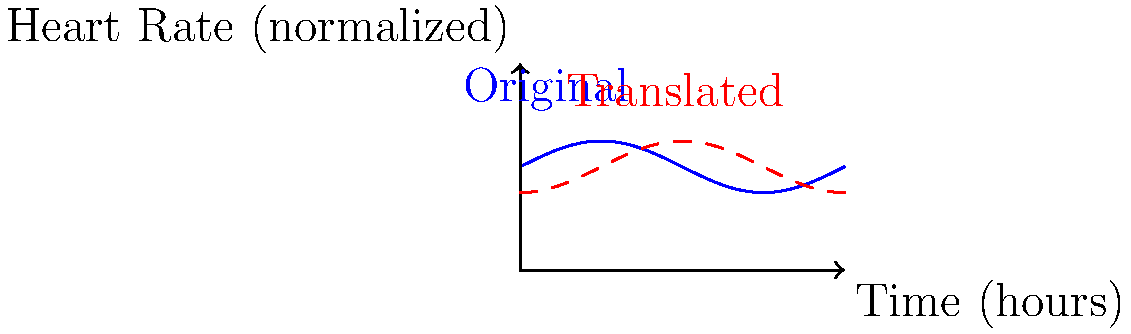A cardiologist is analyzing a patient's heart rate data over time. The blue curve represents the original data, and the red dashed curve shows the same data after a transformation. If the red curve is a translation of the blue curve, by how many hours has the data been shifted? To determine the time shift between the original (blue) and translated (red) curves, we need to analyze the horizontal displacement:

1. Observe that the curves have the same shape, indicating a horizontal translation.
2. The sine function has a period of $2\pi$. In this context, $2\pi$ represents 6 hours (a full cycle of data).
3. The red curve appears to be shifted to the right by $\frac{\pi}{2}$ units compared to the blue curve.
4. To convert this shift from radians to hours:
   
   $\text{Time shift} = \frac{\pi/2}{2\pi} \times 6 \text{ hours}$
   
   $= \frac{1}{4} \times 6 \text{ hours}$
   $= 1.5 \text{ hours}$

5. Therefore, the red curve represents the patient's heart rate data shifted 1.5 hours later than the original blue curve.
Answer: 1.5 hours 